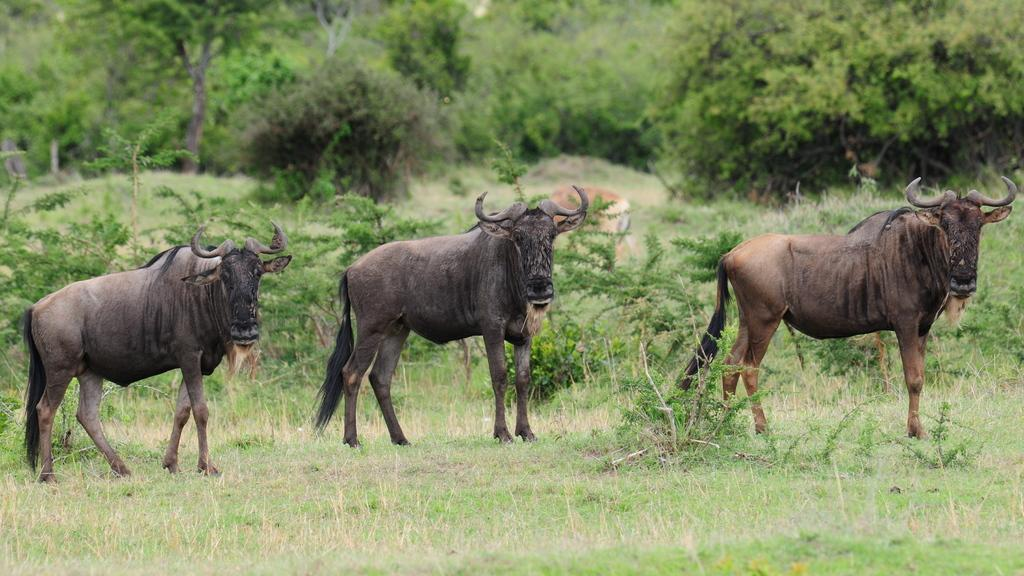What type of surface is visible in the image? There is a grass surface in the image. What animals can be seen on the grass surface? Forest buffaloes are present on the grass surface. What can be seen in the background of the image? There are plants and trees visible in the background of the image. Is there any snow visible in the image? No, there is no snow visible in the image; it features a grass surface and forest buffaloes. Can you tell me how the army is moving through the forest in the image? There is no army present in the image; it features a grass surface, forest buffaloes, plants, and trees. 